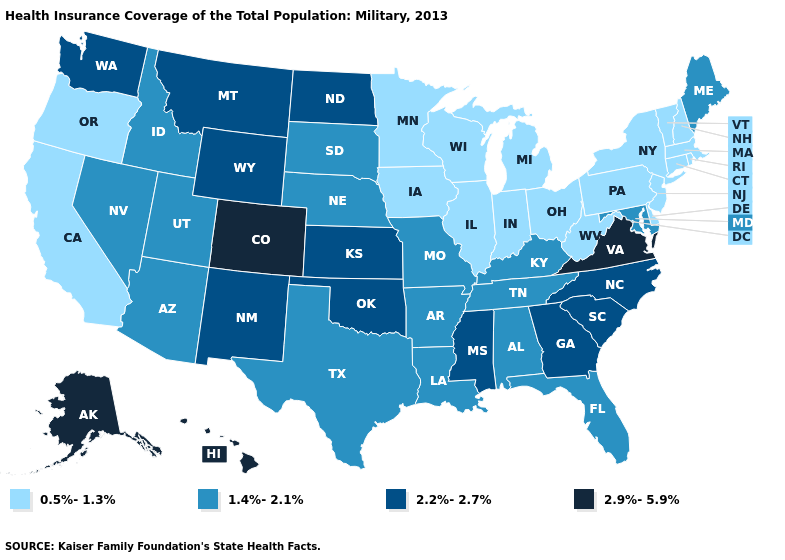What is the value of Massachusetts?
Write a very short answer. 0.5%-1.3%. What is the value of California?
Write a very short answer. 0.5%-1.3%. Name the states that have a value in the range 2.9%-5.9%?
Keep it brief. Alaska, Colorado, Hawaii, Virginia. Name the states that have a value in the range 1.4%-2.1%?
Short answer required. Alabama, Arizona, Arkansas, Florida, Idaho, Kentucky, Louisiana, Maine, Maryland, Missouri, Nebraska, Nevada, South Dakota, Tennessee, Texas, Utah. Among the states that border Iowa , which have the highest value?
Answer briefly. Missouri, Nebraska, South Dakota. What is the value of Missouri?
Answer briefly. 1.4%-2.1%. Does Alaska have the highest value in the USA?
Write a very short answer. Yes. Does South Carolina have a higher value than Delaware?
Be succinct. Yes. Does New Jersey have a lower value than Rhode Island?
Short answer required. No. Name the states that have a value in the range 0.5%-1.3%?
Short answer required. California, Connecticut, Delaware, Illinois, Indiana, Iowa, Massachusetts, Michigan, Minnesota, New Hampshire, New Jersey, New York, Ohio, Oregon, Pennsylvania, Rhode Island, Vermont, West Virginia, Wisconsin. Which states hav the highest value in the Northeast?
Write a very short answer. Maine. Which states hav the highest value in the MidWest?
Be succinct. Kansas, North Dakota. Does Texas have the lowest value in the South?
Keep it brief. No. Among the states that border Maine , which have the highest value?
Write a very short answer. New Hampshire. Which states have the lowest value in the Northeast?
Be succinct. Connecticut, Massachusetts, New Hampshire, New Jersey, New York, Pennsylvania, Rhode Island, Vermont. 